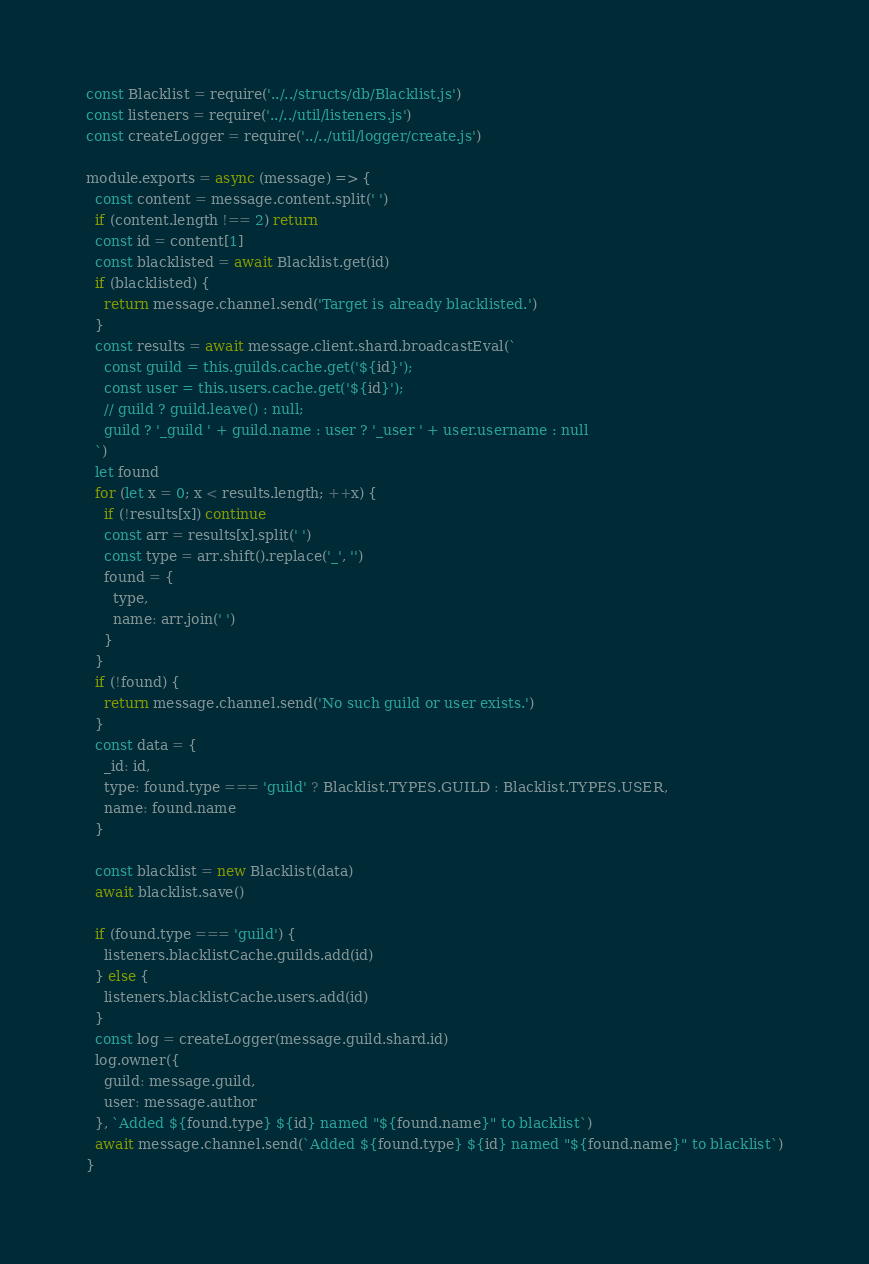Convert code to text. <code><loc_0><loc_0><loc_500><loc_500><_JavaScript_>const Blacklist = require('../../structs/db/Blacklist.js')
const listeners = require('../../util/listeners.js')
const createLogger = require('../../util/logger/create.js')

module.exports = async (message) => {
  const content = message.content.split(' ')
  if (content.length !== 2) return
  const id = content[1]
  const blacklisted = await Blacklist.get(id)
  if (blacklisted) {
    return message.channel.send('Target is already blacklisted.')
  }
  const results = await message.client.shard.broadcastEval(`
    const guild = this.guilds.cache.get('${id}');
    const user = this.users.cache.get('${id}');
    // guild ? guild.leave() : null;
    guild ? '_guild ' + guild.name : user ? '_user ' + user.username : null
  `)
  let found
  for (let x = 0; x < results.length; ++x) {
    if (!results[x]) continue
    const arr = results[x].split(' ')
    const type = arr.shift().replace('_', '')
    found = {
      type,
      name: arr.join(' ')
    }
  }
  if (!found) {
    return message.channel.send('No such guild or user exists.')
  }
  const data = {
    _id: id,
    type: found.type === 'guild' ? Blacklist.TYPES.GUILD : Blacklist.TYPES.USER,
    name: found.name
  }

  const blacklist = new Blacklist(data)
  await blacklist.save()

  if (found.type === 'guild') {
    listeners.blacklistCache.guilds.add(id)
  } else {
    listeners.blacklistCache.users.add(id)
  }
  const log = createLogger(message.guild.shard.id)
  log.owner({
    guild: message.guild,
    user: message.author
  }, `Added ${found.type} ${id} named "${found.name}" to blacklist`)
  await message.channel.send(`Added ${found.type} ${id} named "${found.name}" to blacklist`)
}
</code> 